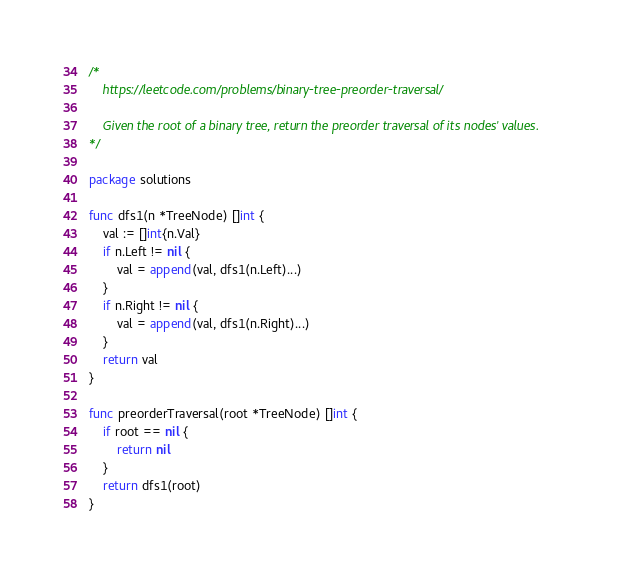Convert code to text. <code><loc_0><loc_0><loc_500><loc_500><_Go_>/*
	https://leetcode.com/problems/binary-tree-preorder-traversal/

	Given the root of a binary tree, return the preorder traversal of its nodes' values.
*/

package solutions

func dfs1(n *TreeNode) []int {
	val := []int{n.Val}
	if n.Left != nil {
		val = append(val, dfs1(n.Left)...)
	}
	if n.Right != nil {
		val = append(val, dfs1(n.Right)...)
	}
	return val
}

func preorderTraversal(root *TreeNode) []int {
	if root == nil {
		return nil
	}
	return dfs1(root)
}
</code> 